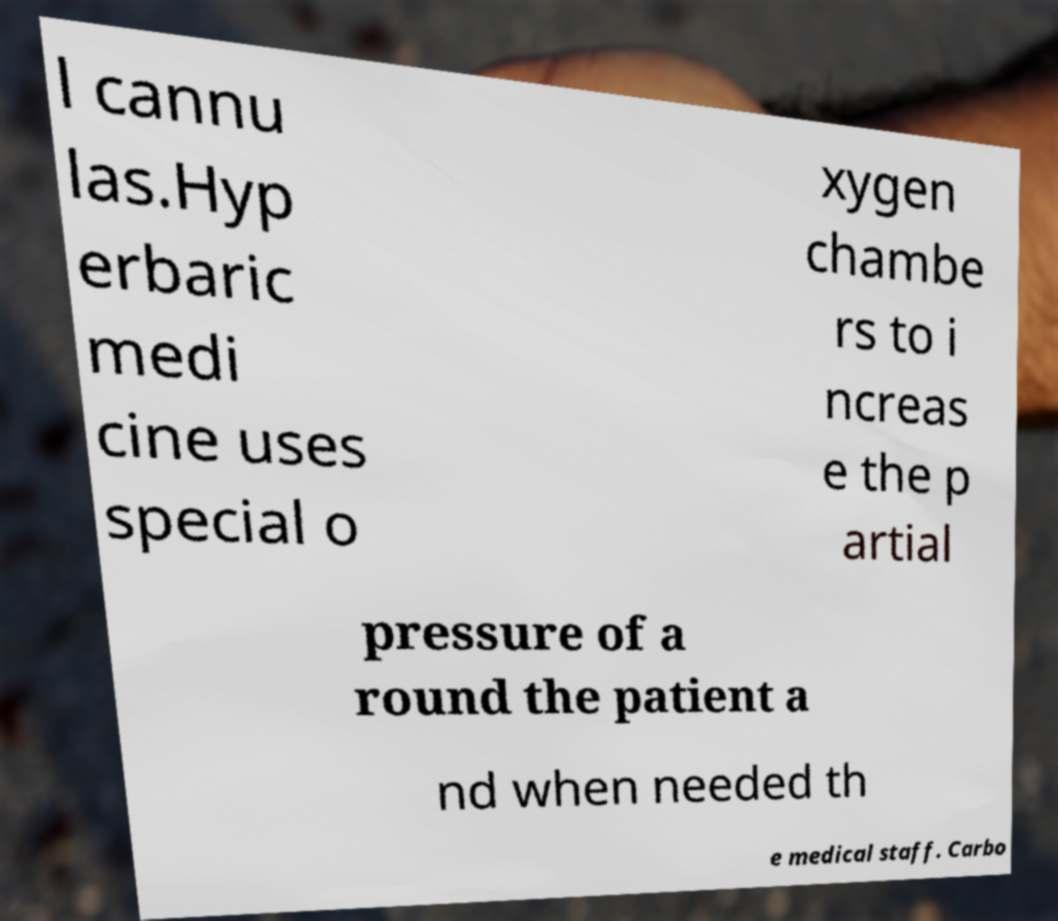Please read and relay the text visible in this image. What does it say? l cannu las.Hyp erbaric medi cine uses special o xygen chambe rs to i ncreas e the p artial pressure of a round the patient a nd when needed th e medical staff. Carbo 